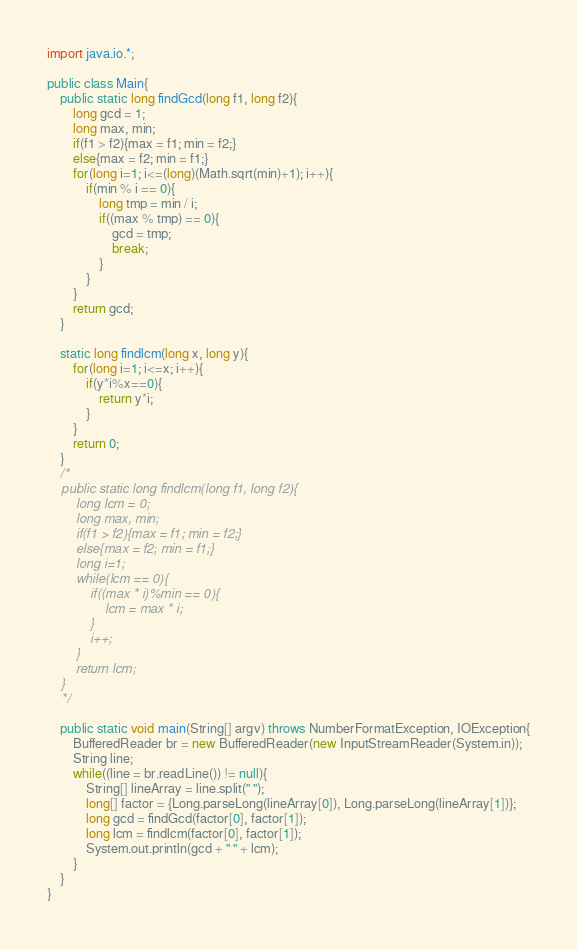Convert code to text. <code><loc_0><loc_0><loc_500><loc_500><_Java_>import java.io.*;

public class Main{
	public static long findGcd(long f1, long f2){
		long gcd = 1;
		long max, min;
		if(f1 > f2){max = f1; min = f2;}
		else{max = f2; min = f1;}
		for(long i=1; i<=(long)(Math.sqrt(min)+1); i++){
			if(min % i == 0){
				long tmp = min / i;
				if((max % tmp) == 0){
					gcd = tmp;
					break;
				}
			}
		}
		return gcd;
	}
	
	static long findlcm(long x, long y){
        for(long i=1; i<=x; i++){
            if(y*i%x==0){
                return y*i;
            }
        }
        return 0;
    }
	/*
	public static long findlcm(long f1, long f2){
		long lcm = 0;
		long max, min;
		if(f1 > f2){max = f1; min = f2;}
		else{max = f2; min = f1;}
		long i=1;
		while(lcm == 0){
			if((max * i)%min == 0){
				lcm = max * i;
			}
			i++;
		}
		return lcm;
	}
	*/
	
	public static void main(String[] argv) throws NumberFormatException, IOException{
		BufferedReader br = new BufferedReader(new InputStreamReader(System.in));
		String line;
		while((line = br.readLine()) != null){
			String[] lineArray = line.split(" ");
			long[] factor = {Long.parseLong(lineArray[0]), Long.parseLong(lineArray[1])};
			long gcd = findGcd(factor[0], factor[1]);
			long lcm = findlcm(factor[0], factor[1]);
			System.out.println(gcd + " " + lcm);
		}
	}
}</code> 